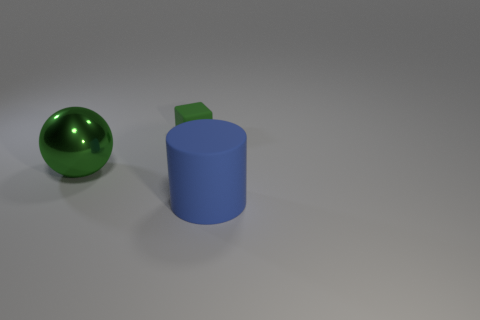What shape is the rubber thing that is to the left of the matte object in front of the green object behind the green ball?
Provide a short and direct response. Cube. What number of gray objects are metal objects or big rubber things?
Give a very brief answer. 0. There is a big object to the left of the small block; what number of green things are behind it?
Keep it short and to the point. 1. Is there any other thing of the same color as the large metal thing?
Ensure brevity in your answer.  Yes. There is a blue thing that is the same material as the green cube; what is its shape?
Give a very brief answer. Cylinder. Does the tiny object have the same color as the shiny object?
Make the answer very short. Yes. Does the large thing on the right side of the matte cube have the same material as the object behind the shiny thing?
Provide a short and direct response. Yes. What number of things are small blocks or rubber objects that are behind the green sphere?
Ensure brevity in your answer.  1. Is there any other thing that has the same material as the big ball?
Your answer should be compact. No. What is the shape of the object that is the same color as the small block?
Keep it short and to the point. Sphere. 